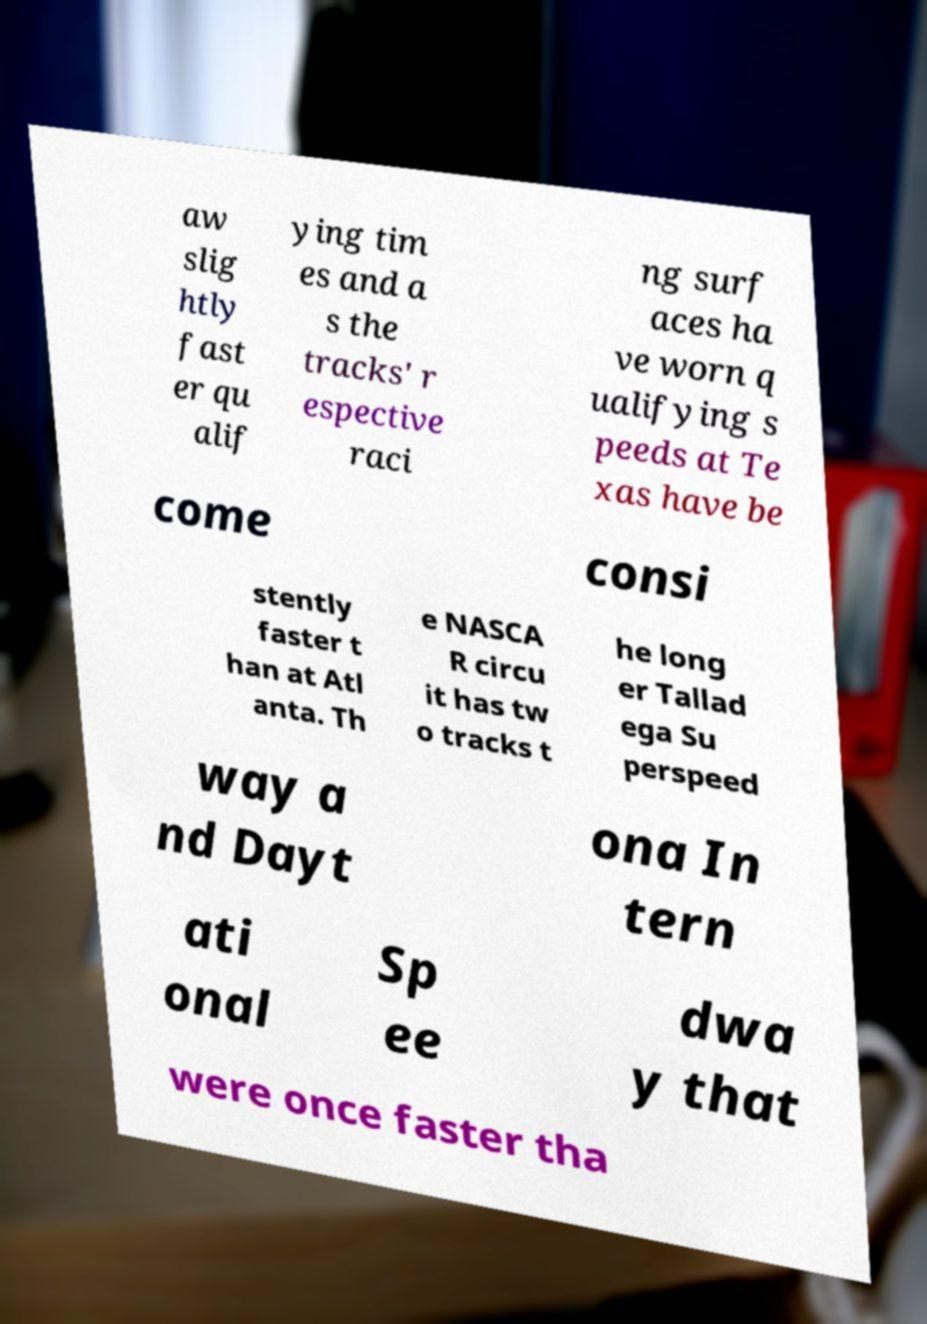For documentation purposes, I need the text within this image transcribed. Could you provide that? aw slig htly fast er qu alif ying tim es and a s the tracks' r espective raci ng surf aces ha ve worn q ualifying s peeds at Te xas have be come consi stently faster t han at Atl anta. Th e NASCA R circu it has tw o tracks t he long er Tallad ega Su perspeed way a nd Dayt ona In tern ati onal Sp ee dwa y that were once faster tha 